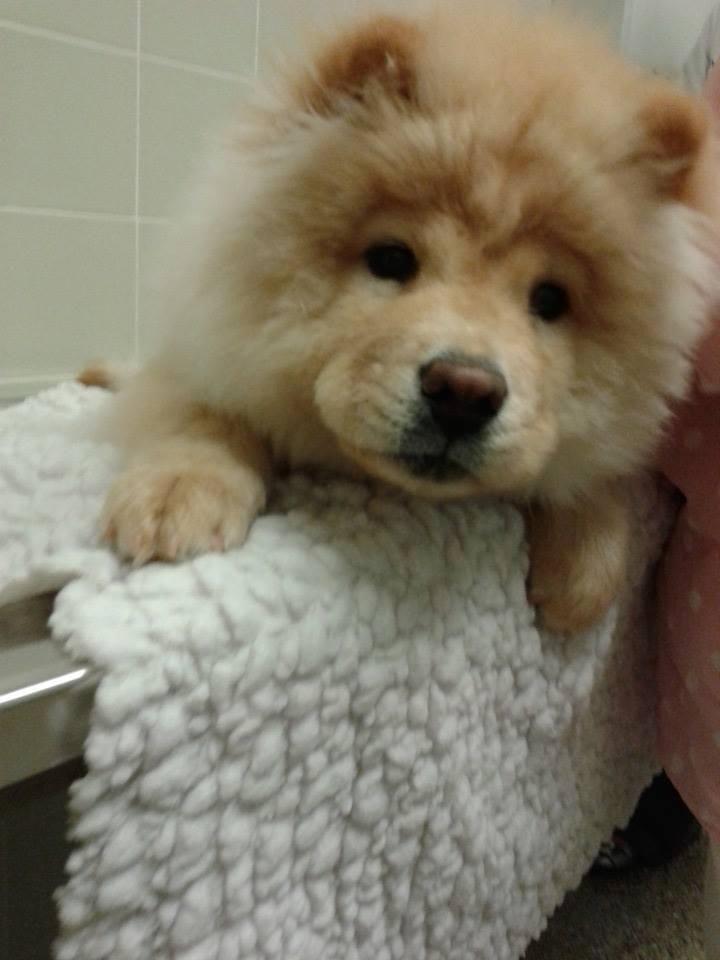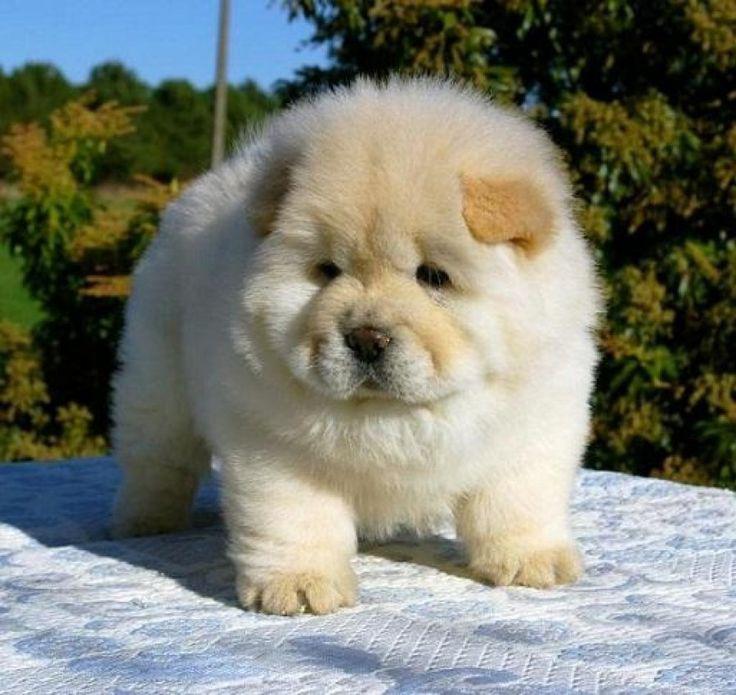The first image is the image on the left, the second image is the image on the right. Assess this claim about the two images: "The dog in the image on the left is outside on a blue mat.". Correct or not? Answer yes or no. No. 